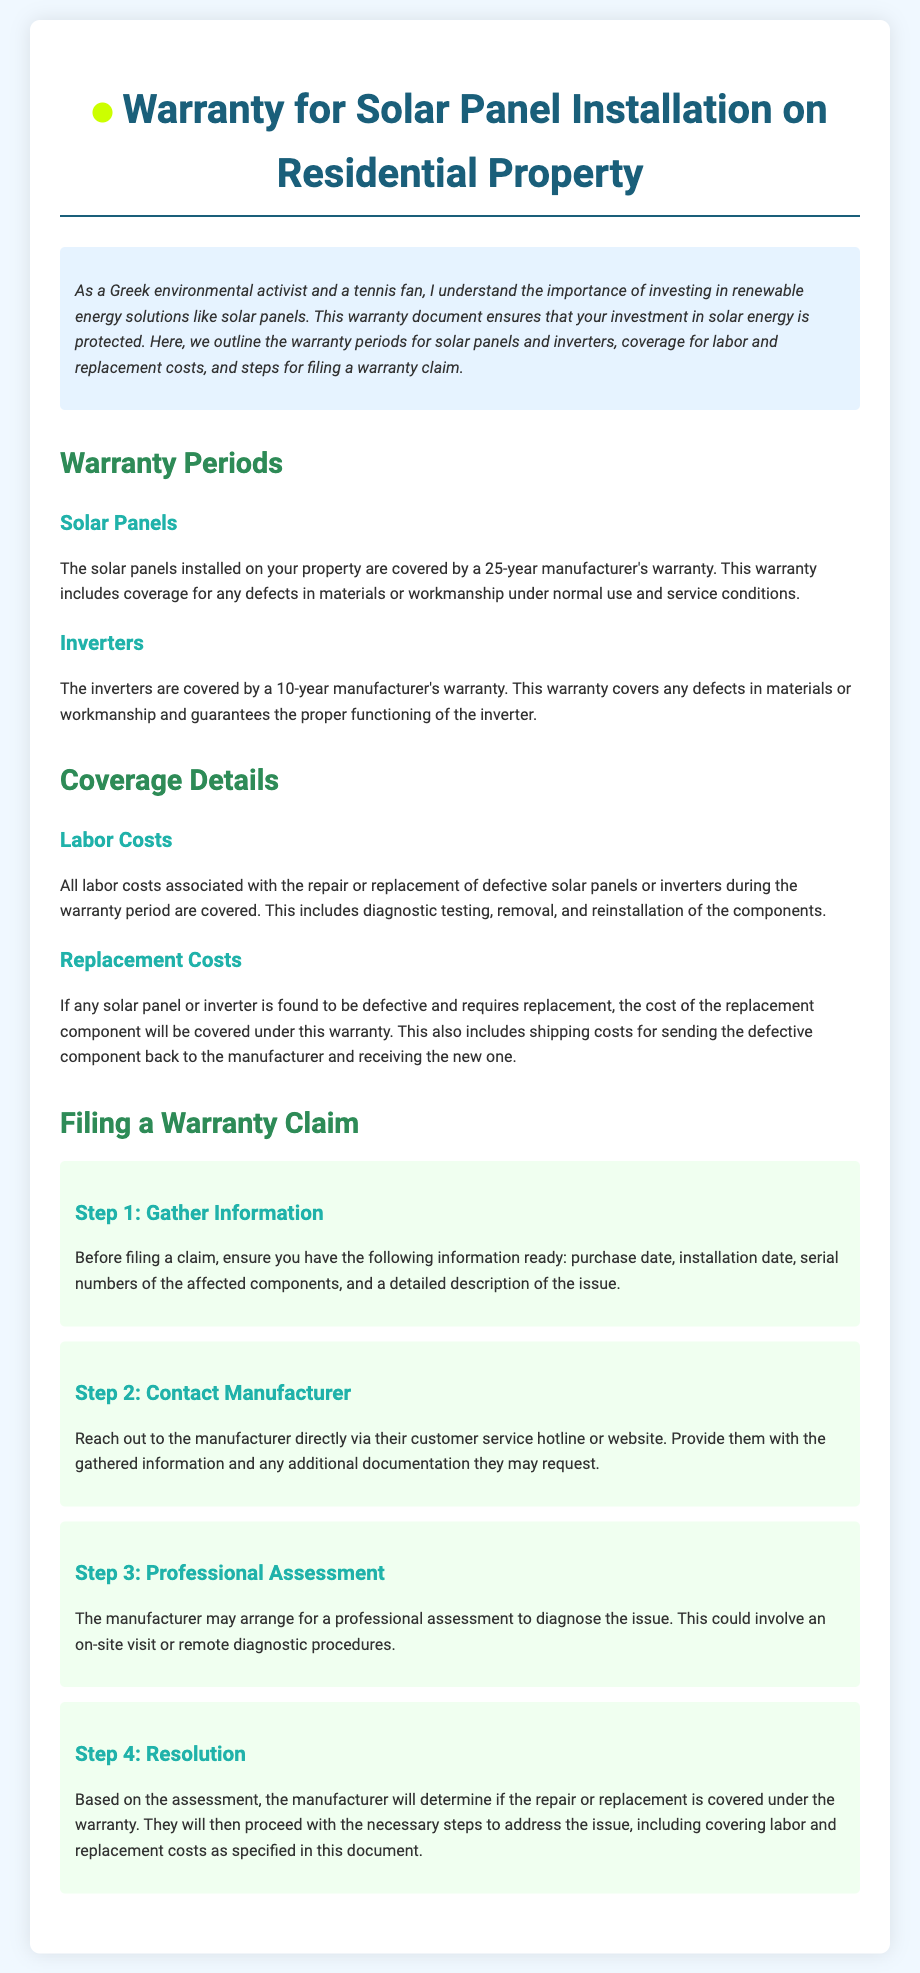What is the warranty period for solar panels? The warranty period for solar panels is specified in the document and is set at 25 years.
Answer: 25 years What is the warranty period for inverters? The warranty period for inverters is mentioned in the document and is set at 10 years.
Answer: 10 years Are labor costs covered under the warranty? The document explicitly states that labor costs associated with repair or replacement during the warranty period are covered.
Answer: Yes What must be gathered before filing a warranty claim? The document lists the necessary information needed before filing a claim, which includes purchase date, installation date, and serial numbers.
Answer: Information Who should be contacted to file a warranty claim? According to the document, the manufacturer should be contacted directly via their customer service hotline or website.
Answer: Manufacturer What could the manufacturer arrange during the warranty claim process? The document mentions that the manufacturer may arrange for a professional assessment to diagnose the issue.
Answer: Professional assessment What is the document's main focus? The main focus of the document is to outline the warranty details for solar panel installation on residential property.
Answer: Warranty details What is included in the coverage for replacement costs? The document specifies that the warranty covers the cost of the replacement component, including shipping costs.
Answer: Replacement component costs 